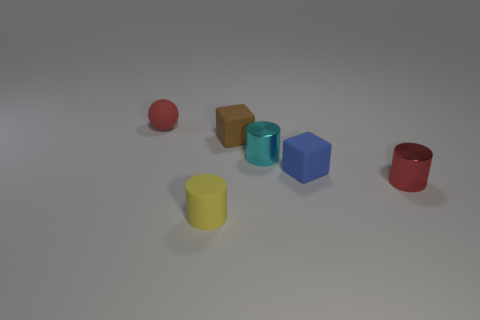Is the size of the red object behind the blue rubber thing the same as the cyan thing?
Provide a short and direct response. Yes. Is there anything else that is the same size as the red cylinder?
Give a very brief answer. Yes. Is the number of yellow things that are left of the red sphere greater than the number of things behind the red cylinder?
Offer a terse response. No. There is a tiny rubber object left of the matte object in front of the red thing in front of the small brown rubber block; what is its color?
Ensure brevity in your answer.  Red. Do the cylinder that is in front of the small red metallic cylinder and the small ball have the same color?
Keep it short and to the point. No. What number of other things are the same color as the sphere?
Give a very brief answer. 1. What number of objects are tiny red matte things or small metallic cylinders?
Keep it short and to the point. 3. What number of objects are either large matte objects or tiny red things to the right of the small brown rubber block?
Offer a very short reply. 1. Is the tiny blue cube made of the same material as the small brown thing?
Give a very brief answer. Yes. What number of other objects are the same material as the small brown thing?
Provide a short and direct response. 3. 